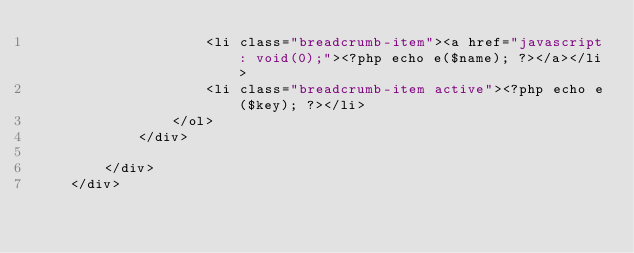Convert code to text. <code><loc_0><loc_0><loc_500><loc_500><_PHP_>                    <li class="breadcrumb-item"><a href="javascript: void(0);"><?php echo e($name); ?></a></li>
                    <li class="breadcrumb-item active"><?php echo e($key); ?></li>
                </ol>
            </div>

        </div>
    </div></code> 